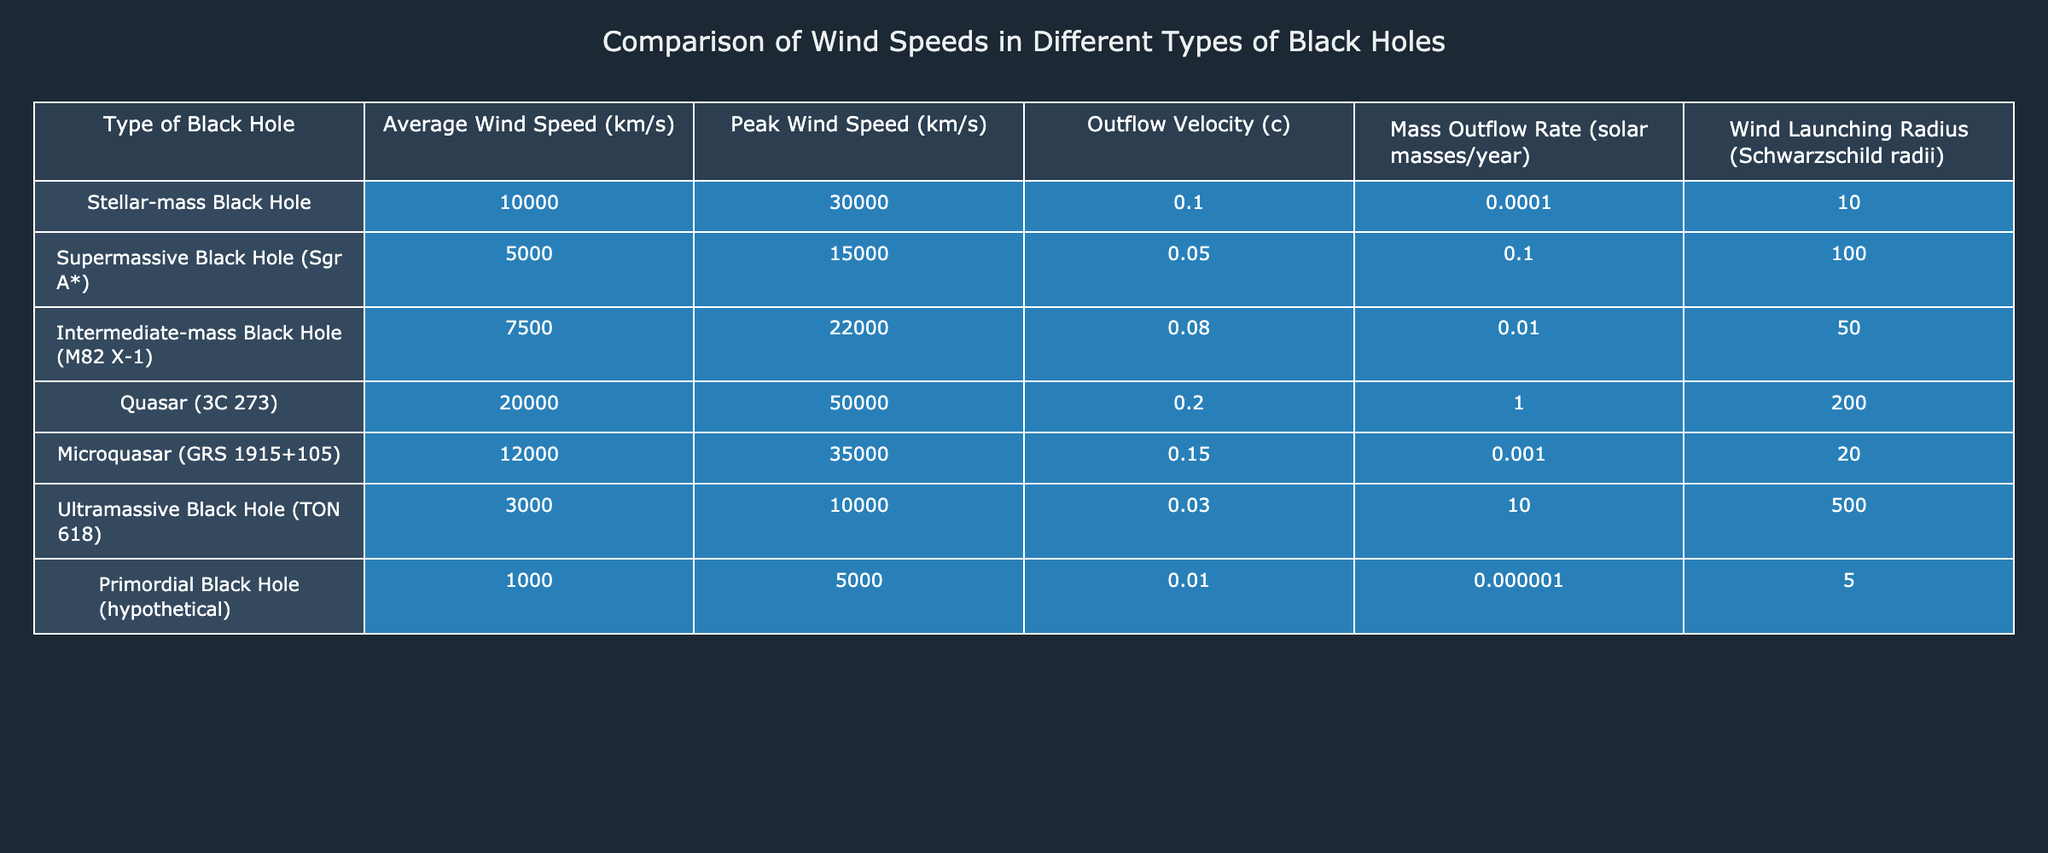What is the average wind speed of the Stellar-mass Black Hole? The average wind speed for the Stellar-mass Black Hole is directly listed in the table, which shows a value of 10000 km/s.
Answer: 10000 km/s Which type of black hole has the highest peak wind speed? The peak wind speeds for different black holes are provided in the table. By comparing the values, the Quasar (3C 273) has the highest peak wind speed of 50000 km/s.
Answer: Quasar (3C 273) How does the average wind speed of Intermediate-mass Black Hole compare to that of Ultramassive Black Hole? The average wind speed of the Intermediate-mass Black Hole is 7500 km/s, while the Ultramassive Black Hole has an average wind speed of 3000 km/s. Therefore, the Intermediate-mass Black Hole has a higher average wind speed by 4500 km/s.
Answer: Intermediate-mass Black Hole is higher by 4500 km/s Is the outflow velocity of the Microquasar greater than that of the Supermassive Black Hole? From the table, the outflow velocity of the Microquasar (0.15) is greater than the Supermassive Black Hole (0.05). Therefore, the statement is true.
Answer: Yes What is the difference in mass outflow rate between the Quasar (3C 273) and the Stellar-mass Black Hole? The mass outflow rate for the Quasar (3C 273) is 1 solar mass/year, while for the Stellar-mass Black Hole, it is 0.0001 solar masses/year. The difference is 1 - 0.0001 = 0.9999 solar masses/year.
Answer: 0.9999 solar masses/year Which type of black hole has the smallest wind launching radius? The table shows the wind launching radius for each type of black hole. The smallest value is 5 Schwarzschild radii, which belongs to the Primordial Black Hole.
Answer: Primordial Black Hole If we were to rank the black holes based on their mass outflow rates from highest to lowest, which would be the second-highest? By looking through the mass outflow rates in the table, the Quasar (3C 273) has the highest at 1, followed by the Supermassive Black Hole with a mass outflow rate of 0.1. Thus, the second-highest is the Supermassive Black Hole.
Answer: Supermassive Black Hole What is the total average wind speed of all black holes listed in the table? The average wind speeds of all black holes sum up to (10000 + 5000 + 7500 + 20000 + 12000 + 3000 + 1000) = 40000 km/s. Dividing this by the total number of black holes (7), we find the average is 40000/7 = about 5714.29 km/s.
Answer: About 5714.29 km/s 